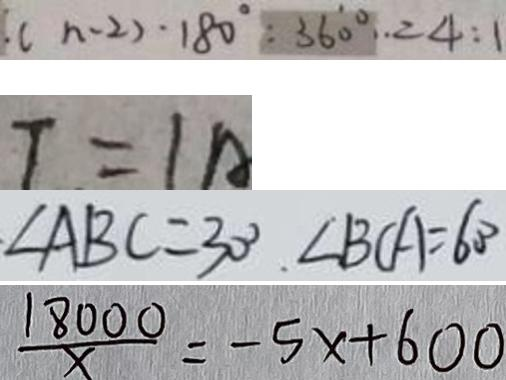Convert formula to latex. <formula><loc_0><loc_0><loc_500><loc_500>( n - 2 ) \cdot 1 8 0 ^ { \circ } : 3 6 0 ^ { \circ } = 4 : 1 
 T = 1 A 
 \angle A B C = 3 0 ^ { \circ } \angle B C A = 6 0 ^ { \circ } 
 \frac { 1 8 0 0 0 } { x } = - 5 x + 6 0 0</formula> 